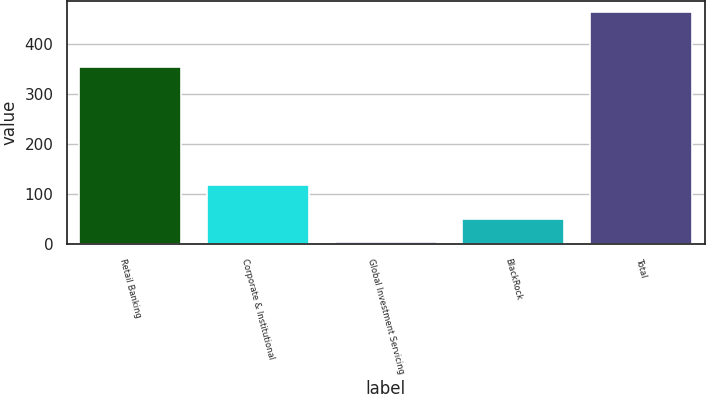Convert chart. <chart><loc_0><loc_0><loc_500><loc_500><bar_chart><fcel>Retail Banking<fcel>Corporate & Institutional<fcel>Global Investment Servicing<fcel>BlackRock<fcel>Total<nl><fcel>354<fcel>118<fcel>4<fcel>49.9<fcel>463<nl></chart> 